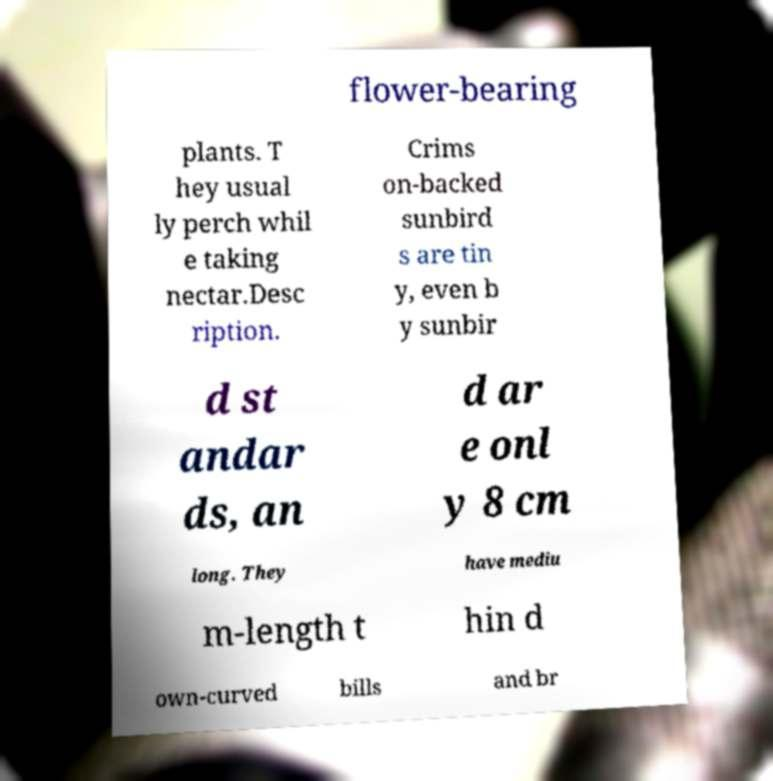Please read and relay the text visible in this image. What does it say? flower-bearing plants. T hey usual ly perch whil e taking nectar.Desc ription. Crims on-backed sunbird s are tin y, even b y sunbir d st andar ds, an d ar e onl y 8 cm long. They have mediu m-length t hin d own-curved bills and br 